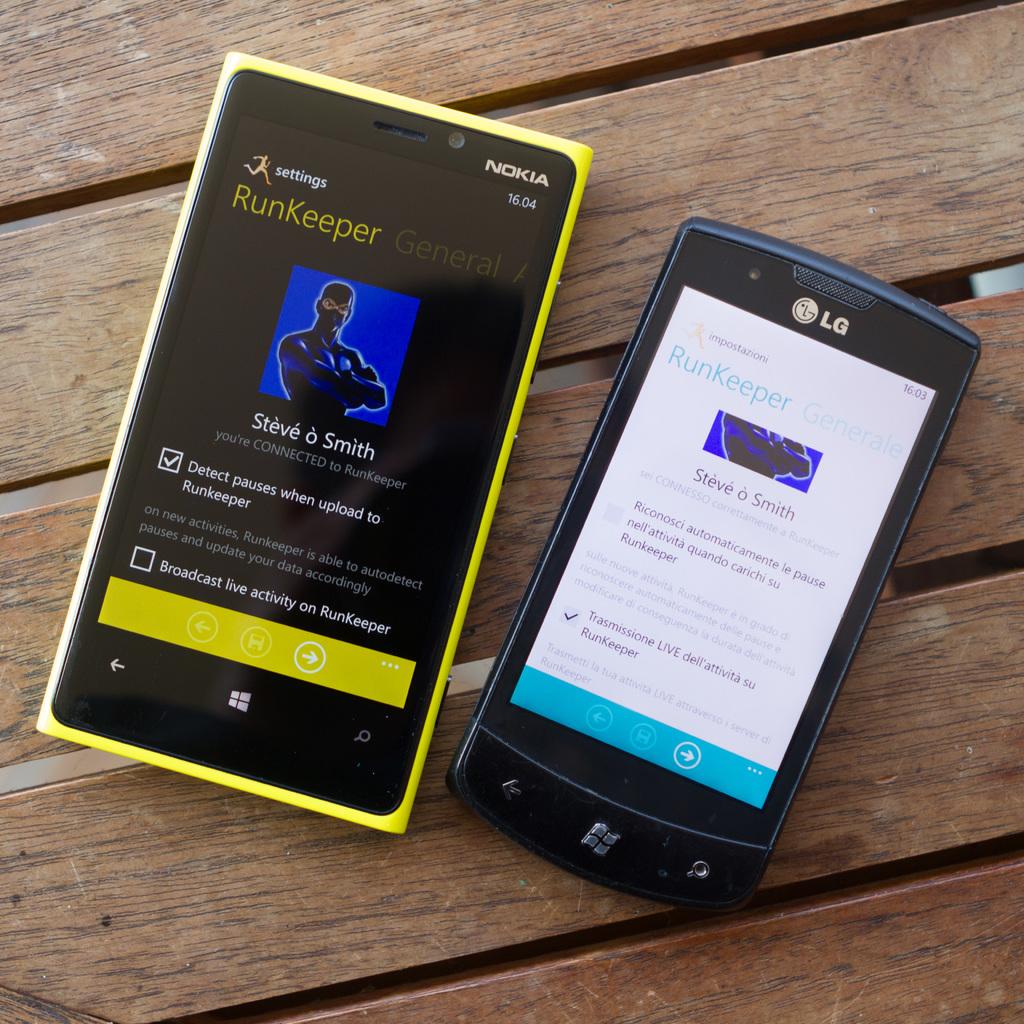What brand of phone?
Make the answer very short. Lg. What musical artist is featured on the yellow phone?
Keep it short and to the point. Steve o smith. 